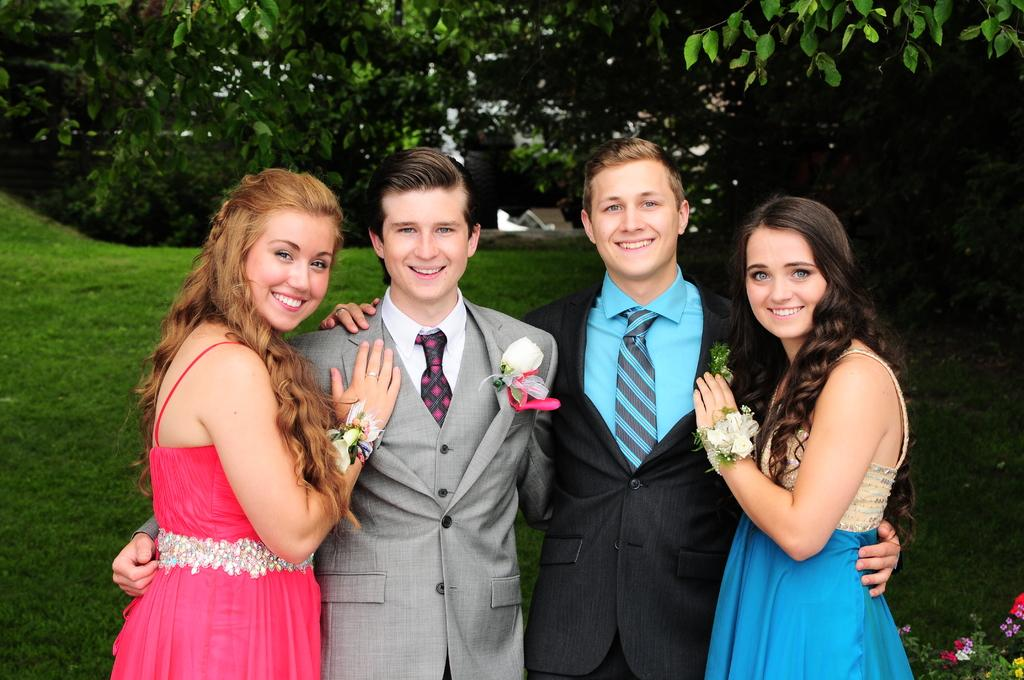How many people are in the image? There is a group of people in the image. What are the people doing in the image? The people are standing and smiling. What are the people wearing in the image? The people are wearing suits. What can be seen in the background of the image? There are trees in the background of the image. What type of vegetation is visible in the image? There is grass visible in the image. What caption would best describe the image? There is no caption provided with the image, so it cannot be determined. Can you see any ducks in the image? There are no ducks present in the image. Is there any indication of a war or conflict in the image? There is no indication of a war or conflict in the image; the people are smiling and wearing suits. 